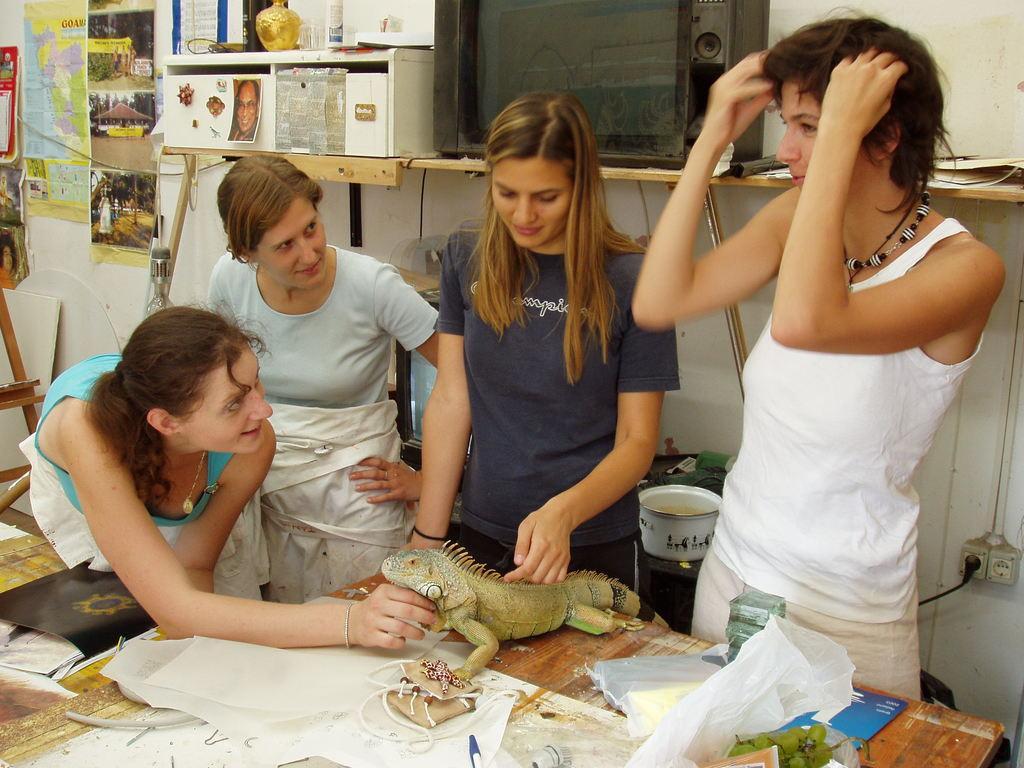Can you describe this image briefly? In this image in the center there are group of persons standing. In the center there is table on the table there are papers and there is model of the lizard. In the background there are posters on the wall and there is a television on the shelf, and there is a plug and there is an object which is white in colour. 